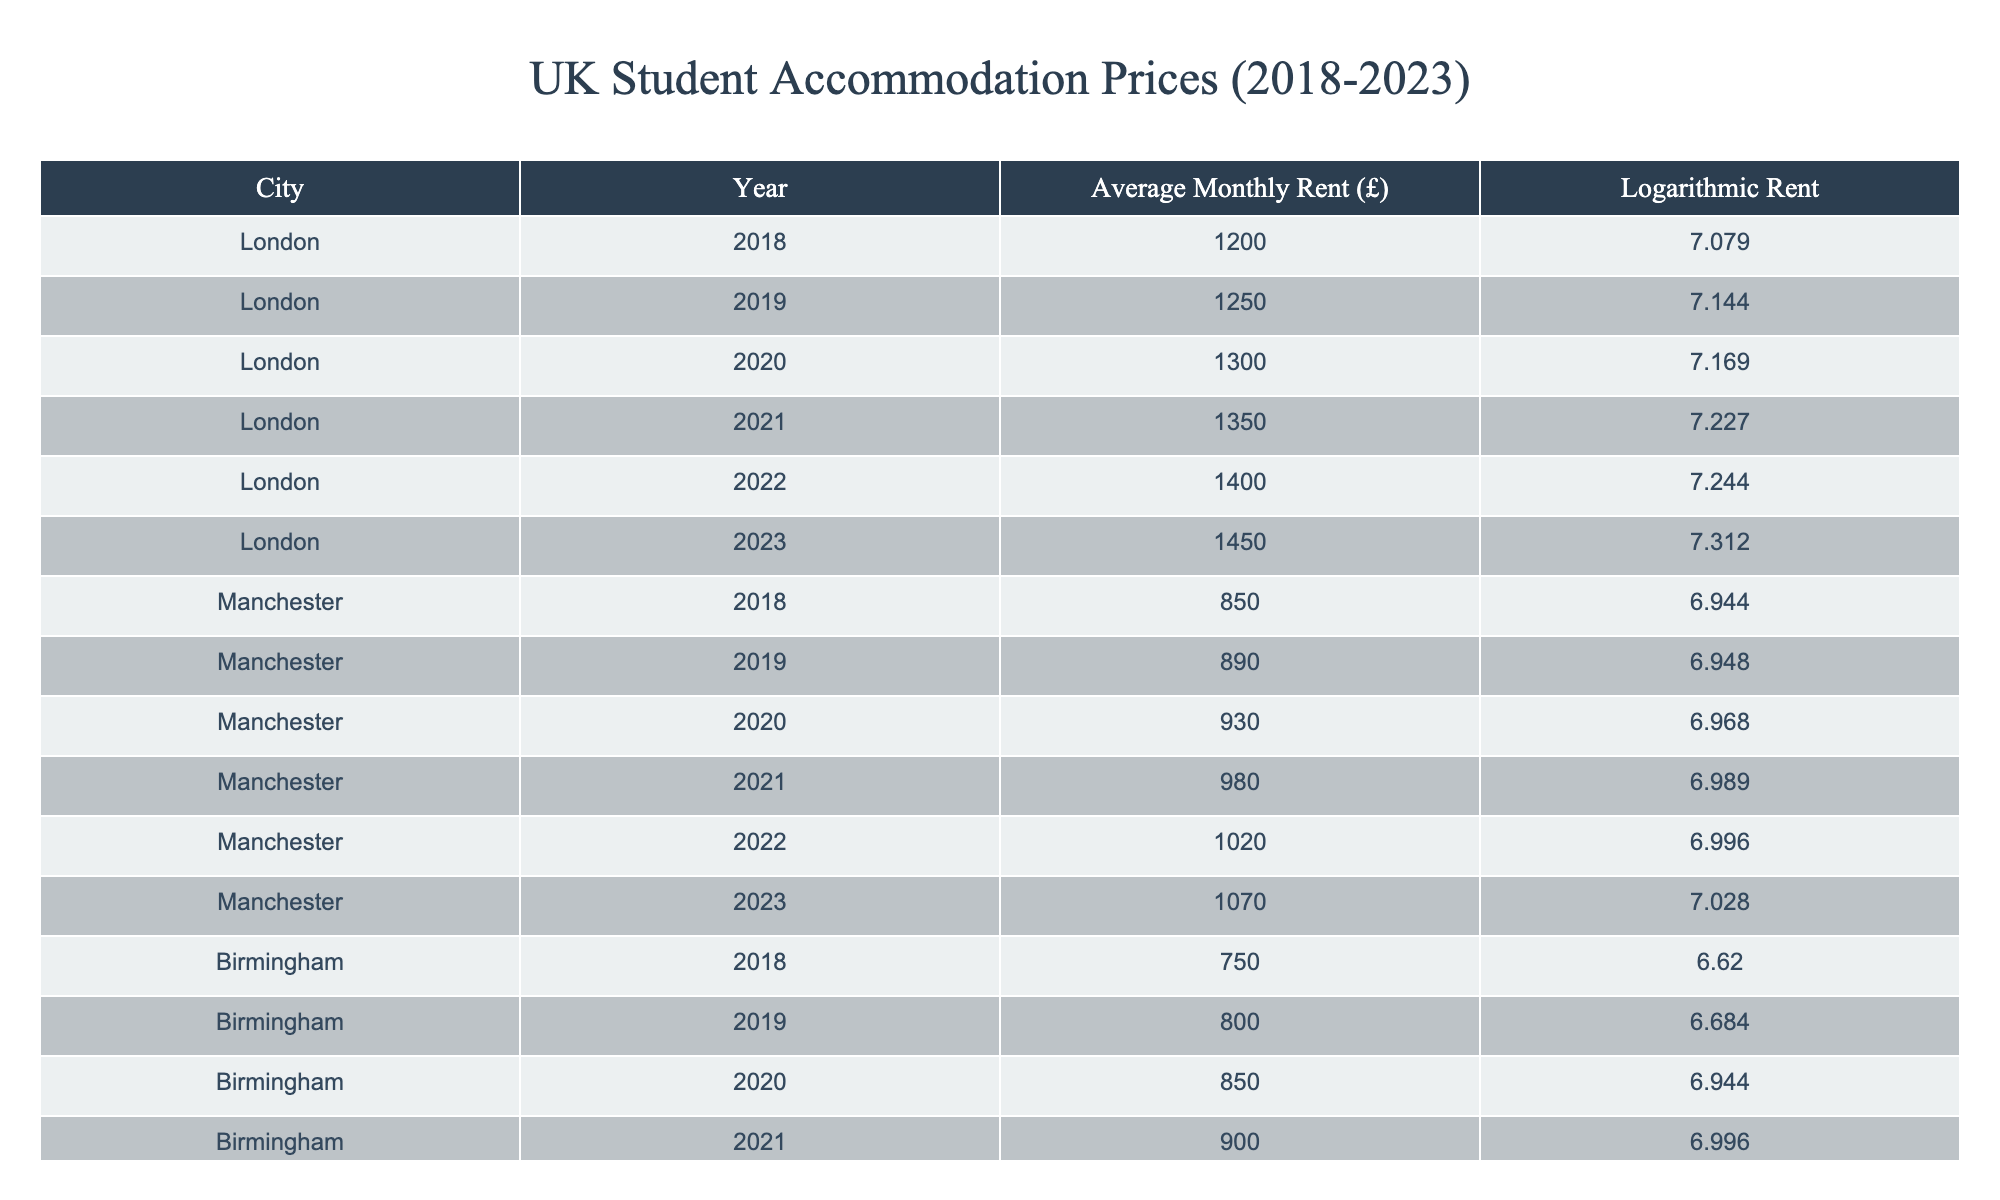What was the average monthly rent in London in 2020? In the table, the average monthly rent in London for 2020 is specifically listed under the "Average Monthly Rent (£)" column as 1300.
Answer: 1300 Which city had the highest average monthly rent in 2021? By looking at the "Average Monthly Rent (£)" for each city in 2021, London has 1350, which is higher than Manchester (980), Birmingham (900), Edinburgh (1100), and Liverpool (800).
Answer: London What is the difference in average rent between Birmingham in 2018 and in 2023? The average rent in Birmingham in 2018 is 750, and in 2023 it is 1000. The difference is calculated as 1000 - 750 = 250.
Answer: 250 True or False: The logarithmic rent in Manchester was higher than in Birmingham every year from 2018 to 2023. To find out, we check the "Logarithmic Rent" for both cities across the years. Manchester's rents (6.944, 6.948, 6.968, 6.989, 6.996, 7.028) are higher than Birmingham's rents (6.620, 6.684, 6.944, 6.996, 6.988, 6.908) from 2018 to 2023, except for 2020 where both are equal. Thus, the statement is False.
Answer: False What is the average average monthly rent for all cities combined in 2022? First, we sum the rents for each city in 2022: London (1400) + Manchester (1020) + Birmingham (950) + Edinburgh (1150) + Liverpool (850) = 4370. Then, we divide by the number of cities (5): 4370 / 5 = 874.
Answer: 874 Which city had the smallest increase in average monthly rent from 2018 to 2023? We calculate the increase for each city: London (1450 - 1200 = 250), Manchester (1070 - 850 = 220), Birmingham (1000 - 750 = 250), Edinburgh (1200 - 950 = 250), and Liverpool (900 - 700 = 200). The smallest increase is in Liverpool with 200.
Answer: Liverpool What was the average annual increase in average rent in London from 2018 to 2023? Calculate the total increase over the years: 1450 - 1200 = 250. Then, divide by the number of years (2023 - 2018 = 5): 250 / 5 = 50.
Answer: 50 Was there a year when rents decreased in any city? By reviewing the rents year by year for each city, we can see that all cities' rents either increased or remained the same; therefore, no year had a decrease.
Answer: No 